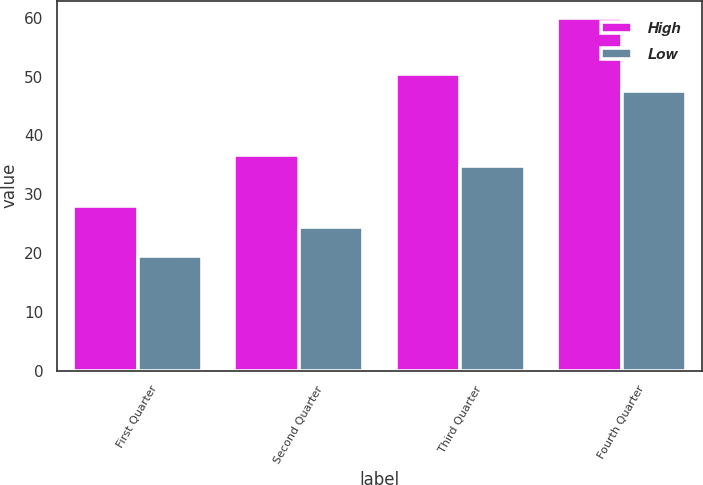Convert chart to OTSL. <chart><loc_0><loc_0><loc_500><loc_500><stacked_bar_chart><ecel><fcel>First Quarter<fcel>Second Quarter<fcel>Third Quarter<fcel>Fourth Quarter<nl><fcel>High<fcel>27.93<fcel>36.72<fcel>50.44<fcel>59.91<nl><fcel>Low<fcel>19.57<fcel>24.38<fcel>34.87<fcel>47.58<nl></chart> 